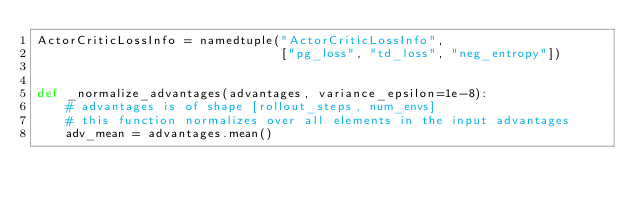Convert code to text. <code><loc_0><loc_0><loc_500><loc_500><_Python_>ActorCriticLossInfo = namedtuple("ActorCriticLossInfo",
                                 ["pg_loss", "td_loss", "neg_entropy"])


def _normalize_advantages(advantages, variance_epsilon=1e-8):
    # advantages is of shape [rollout_steps, num_envs]
    # this function normalizes over all elements in the input advantages
    adv_mean = advantages.mean()</code> 